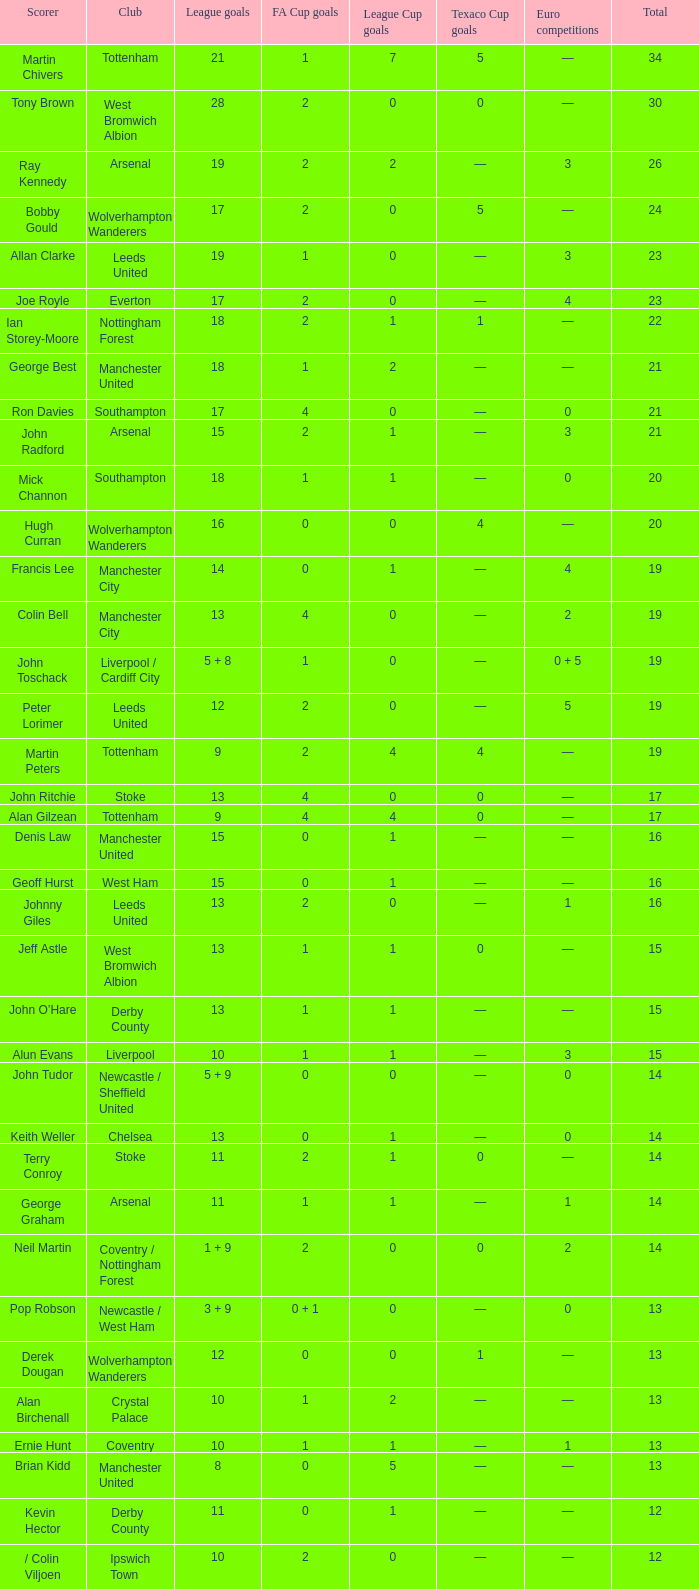What is the average Total, when FA Cup Goals is 1, when League Goals is 10, and when Club is Crystal Palace? 13.0. 